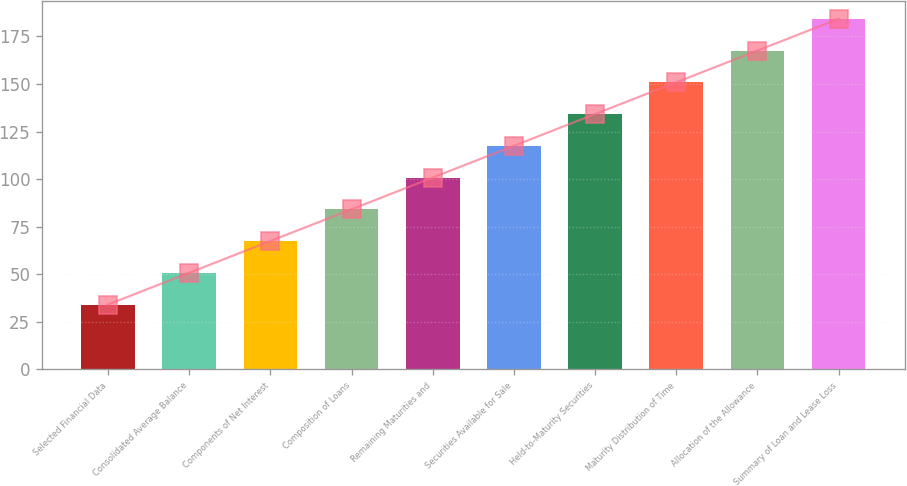Convert chart. <chart><loc_0><loc_0><loc_500><loc_500><bar_chart><fcel>Selected Financial Data<fcel>Consolidated Average Balance<fcel>Components of Net Interest<fcel>Composition of Loans<fcel>Remaining Maturities and<fcel>Securities Available for Sale<fcel>Held-to-Maturity Securities<fcel>Maturity Distribution of Time<fcel>Allocation of the Allowance<fcel>Summary of Loan and Lease Loss<nl><fcel>34<fcel>50.7<fcel>67.4<fcel>84.1<fcel>100.8<fcel>117.5<fcel>134.2<fcel>150.9<fcel>167.6<fcel>184.3<nl></chart> 